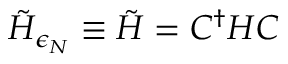Convert formula to latex. <formula><loc_0><loc_0><loc_500><loc_500>\tilde { H } _ { \epsilon _ { N } } \equiv \tilde { H } = C ^ { \dagger } H C</formula> 